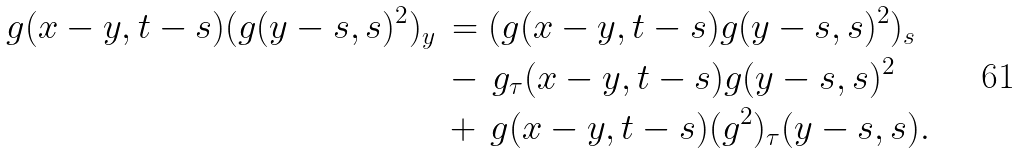<formula> <loc_0><loc_0><loc_500><loc_500>g ( x - y , t - s ) ( g ( y - s , s ) ^ { 2 } ) _ { y } \, & = ( g ( x - y , t - s ) g ( y - s , s ) ^ { 2 } ) _ { s } \\ & - \, g _ { \tau } ( x - y , t - s ) g ( y - s , s ) ^ { 2 } \\ & + \, g ( x - y , t - s ) ( g ^ { 2 } ) _ { \tau } ( y - s , s ) .</formula> 